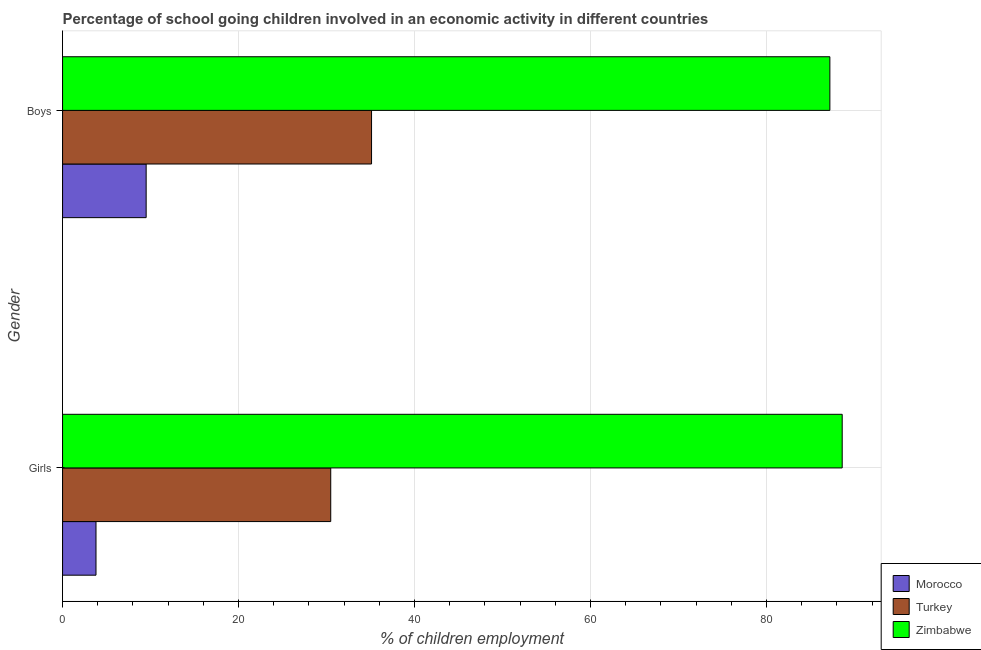How many groups of bars are there?
Your answer should be very brief. 2. How many bars are there on the 2nd tick from the top?
Your response must be concise. 3. How many bars are there on the 2nd tick from the bottom?
Ensure brevity in your answer.  3. What is the label of the 2nd group of bars from the top?
Your answer should be very brief. Girls. What is the percentage of school going girls in Turkey?
Provide a succinct answer. 30.48. Across all countries, what is the maximum percentage of school going girls?
Provide a succinct answer. 88.6. Across all countries, what is the minimum percentage of school going girls?
Your answer should be very brief. 3.8. In which country was the percentage of school going girls maximum?
Provide a succinct answer. Zimbabwe. In which country was the percentage of school going boys minimum?
Offer a very short reply. Morocco. What is the total percentage of school going girls in the graph?
Provide a short and direct response. 122.88. What is the difference between the percentage of school going girls in Morocco and that in Zimbabwe?
Your answer should be very brief. -84.8. What is the difference between the percentage of school going boys in Turkey and the percentage of school going girls in Zimbabwe?
Give a very brief answer. -53.49. What is the average percentage of school going girls per country?
Give a very brief answer. 40.96. What is the difference between the percentage of school going girls and percentage of school going boys in Turkey?
Provide a succinct answer. -4.64. In how many countries, is the percentage of school going girls greater than 76 %?
Your answer should be very brief. 1. What is the ratio of the percentage of school going boys in Morocco to that in Zimbabwe?
Offer a terse response. 0.11. What does the 1st bar from the top in Boys represents?
Provide a succinct answer. Zimbabwe. What does the 3rd bar from the bottom in Boys represents?
Provide a short and direct response. Zimbabwe. How many bars are there?
Provide a succinct answer. 6. Are all the bars in the graph horizontal?
Make the answer very short. Yes. How many countries are there in the graph?
Make the answer very short. 3. What is the difference between two consecutive major ticks on the X-axis?
Your response must be concise. 20. Are the values on the major ticks of X-axis written in scientific E-notation?
Your answer should be compact. No. Does the graph contain grids?
Keep it short and to the point. Yes. Where does the legend appear in the graph?
Your response must be concise. Bottom right. How are the legend labels stacked?
Offer a very short reply. Vertical. What is the title of the graph?
Provide a short and direct response. Percentage of school going children involved in an economic activity in different countries. Does "Botswana" appear as one of the legend labels in the graph?
Offer a terse response. No. What is the label or title of the X-axis?
Your answer should be compact. % of children employment. What is the % of children employment of Turkey in Girls?
Offer a very short reply. 30.48. What is the % of children employment of Zimbabwe in Girls?
Give a very brief answer. 88.6. What is the % of children employment in Morocco in Boys?
Make the answer very short. 9.5. What is the % of children employment of Turkey in Boys?
Your answer should be compact. 35.11. What is the % of children employment in Zimbabwe in Boys?
Make the answer very short. 87.2. Across all Gender, what is the maximum % of children employment in Morocco?
Offer a terse response. 9.5. Across all Gender, what is the maximum % of children employment of Turkey?
Ensure brevity in your answer.  35.11. Across all Gender, what is the maximum % of children employment of Zimbabwe?
Provide a short and direct response. 88.6. Across all Gender, what is the minimum % of children employment in Morocco?
Your answer should be very brief. 3.8. Across all Gender, what is the minimum % of children employment in Turkey?
Ensure brevity in your answer.  30.48. Across all Gender, what is the minimum % of children employment of Zimbabwe?
Provide a succinct answer. 87.2. What is the total % of children employment in Morocco in the graph?
Your answer should be compact. 13.3. What is the total % of children employment of Turkey in the graph?
Make the answer very short. 65.59. What is the total % of children employment in Zimbabwe in the graph?
Your response must be concise. 175.8. What is the difference between the % of children employment in Morocco in Girls and that in Boys?
Provide a short and direct response. -5.7. What is the difference between the % of children employment of Turkey in Girls and that in Boys?
Provide a succinct answer. -4.64. What is the difference between the % of children employment in Morocco in Girls and the % of children employment in Turkey in Boys?
Provide a short and direct response. -31.31. What is the difference between the % of children employment in Morocco in Girls and the % of children employment in Zimbabwe in Boys?
Make the answer very short. -83.4. What is the difference between the % of children employment in Turkey in Girls and the % of children employment in Zimbabwe in Boys?
Offer a terse response. -56.72. What is the average % of children employment of Morocco per Gender?
Make the answer very short. 6.65. What is the average % of children employment of Turkey per Gender?
Keep it short and to the point. 32.79. What is the average % of children employment in Zimbabwe per Gender?
Offer a terse response. 87.9. What is the difference between the % of children employment in Morocco and % of children employment in Turkey in Girls?
Keep it short and to the point. -26.68. What is the difference between the % of children employment in Morocco and % of children employment in Zimbabwe in Girls?
Give a very brief answer. -84.8. What is the difference between the % of children employment of Turkey and % of children employment of Zimbabwe in Girls?
Provide a succinct answer. -58.12. What is the difference between the % of children employment in Morocco and % of children employment in Turkey in Boys?
Your answer should be compact. -25.61. What is the difference between the % of children employment of Morocco and % of children employment of Zimbabwe in Boys?
Your answer should be compact. -77.7. What is the difference between the % of children employment in Turkey and % of children employment in Zimbabwe in Boys?
Provide a short and direct response. -52.09. What is the ratio of the % of children employment of Turkey in Girls to that in Boys?
Offer a terse response. 0.87. What is the ratio of the % of children employment in Zimbabwe in Girls to that in Boys?
Your response must be concise. 1.02. What is the difference between the highest and the second highest % of children employment of Morocco?
Offer a very short reply. 5.7. What is the difference between the highest and the second highest % of children employment of Turkey?
Provide a succinct answer. 4.64. What is the difference between the highest and the second highest % of children employment of Zimbabwe?
Offer a terse response. 1.4. What is the difference between the highest and the lowest % of children employment of Turkey?
Ensure brevity in your answer.  4.64. 